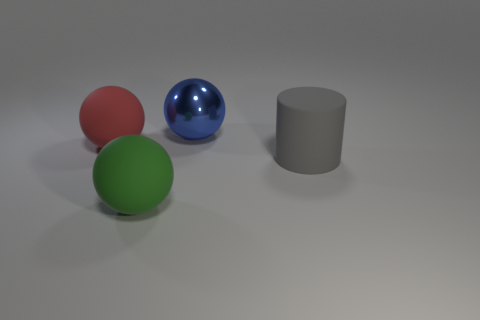What number of objects are either balls that are behind the cylinder or things left of the large gray object?
Give a very brief answer. 3. Are there any rubber things on the right side of the large green rubber object?
Provide a short and direct response. Yes. How many things are either rubber things that are behind the large green thing or tiny gray metallic cubes?
Provide a short and direct response. 2. What number of purple objects are shiny spheres or big matte things?
Keep it short and to the point. 0. Is the number of gray cylinders that are in front of the green thing less than the number of small cyan spheres?
Your response must be concise. No. What color is the big sphere in front of the sphere on the left side of the large rubber ball on the right side of the big red matte object?
Your answer should be compact. Green. Is there any other thing that is the same material as the big blue thing?
Provide a short and direct response. No. What is the size of the red thing that is the same shape as the green object?
Offer a very short reply. Large. Are there fewer large red objects in front of the green matte sphere than large red spheres that are on the right side of the blue thing?
Your answer should be very brief. No. What is the shape of the thing that is both in front of the red object and right of the green sphere?
Make the answer very short. Cylinder. 